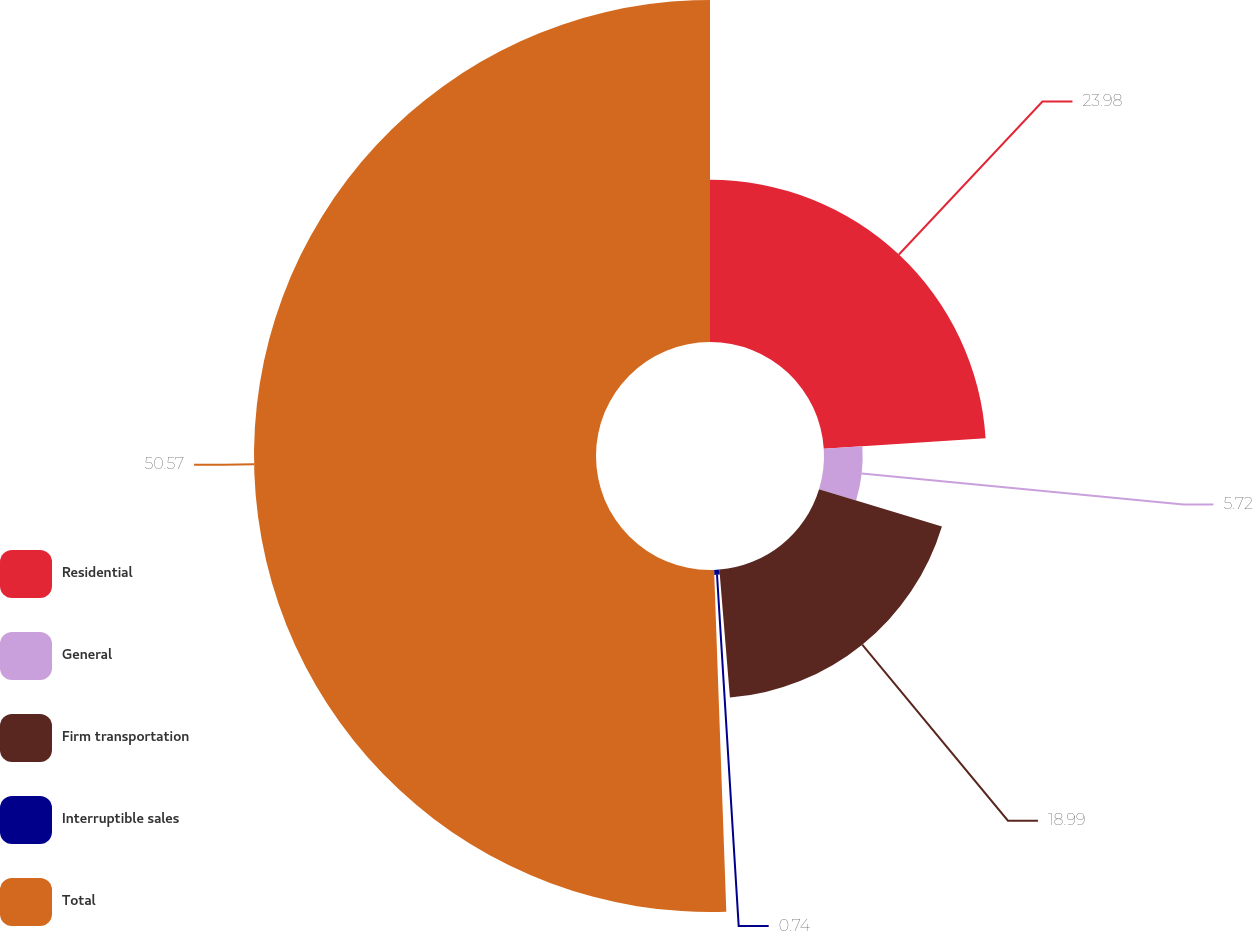Convert chart. <chart><loc_0><loc_0><loc_500><loc_500><pie_chart><fcel>Residential<fcel>General<fcel>Firm transportation<fcel>Interruptible sales<fcel>Total<nl><fcel>23.98%<fcel>5.72%<fcel>18.99%<fcel>0.74%<fcel>50.57%<nl></chart> 